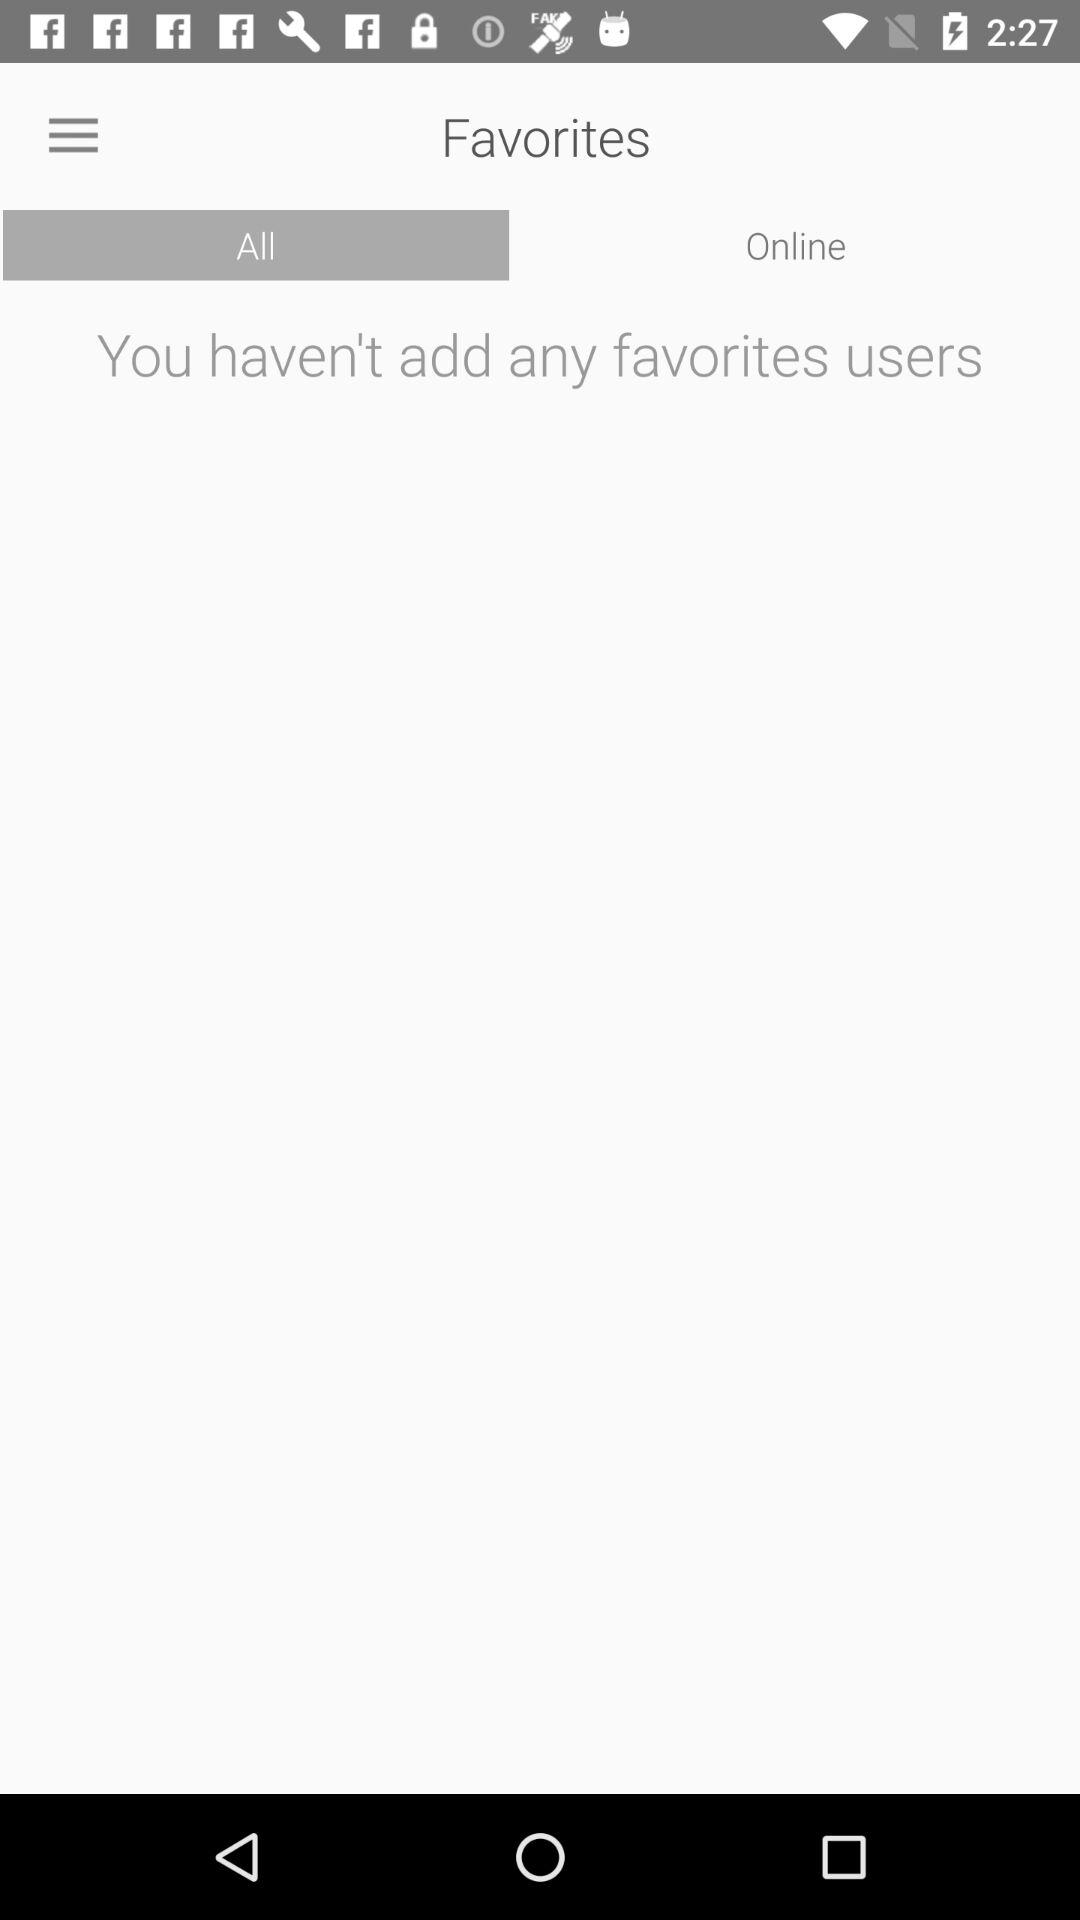Which tab is selected? The selected tab is All. 